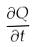<formula> <loc_0><loc_0><loc_500><loc_500>\frac { \partial Q } { \partial t }</formula> 